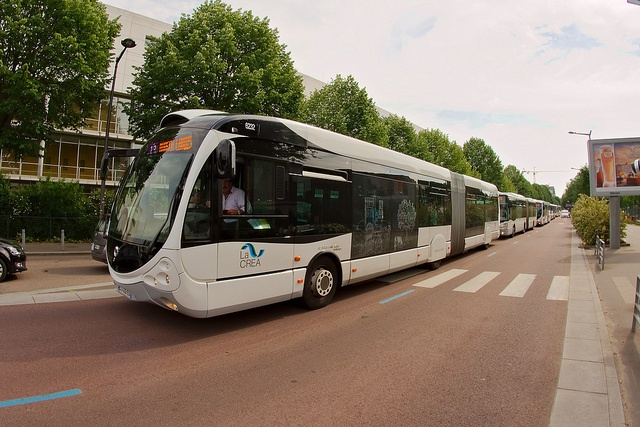Describe the objects in this image and their specific colors. I can see bus in black, darkgray, and gray tones, bus in black, gray, darkgray, and darkgreen tones, car in black, gray, and darkgray tones, people in black, gray, and maroon tones, and car in black and gray tones in this image. 